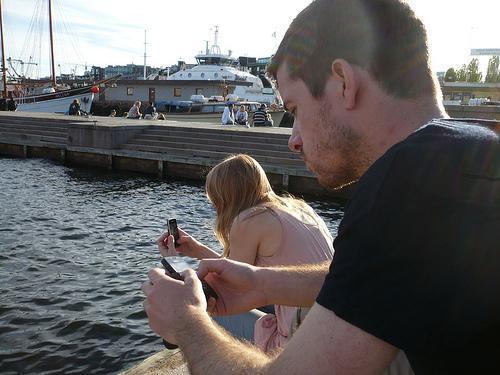How many people are there?
Give a very brief answer. 2. How many boats are there?
Give a very brief answer. 1. 